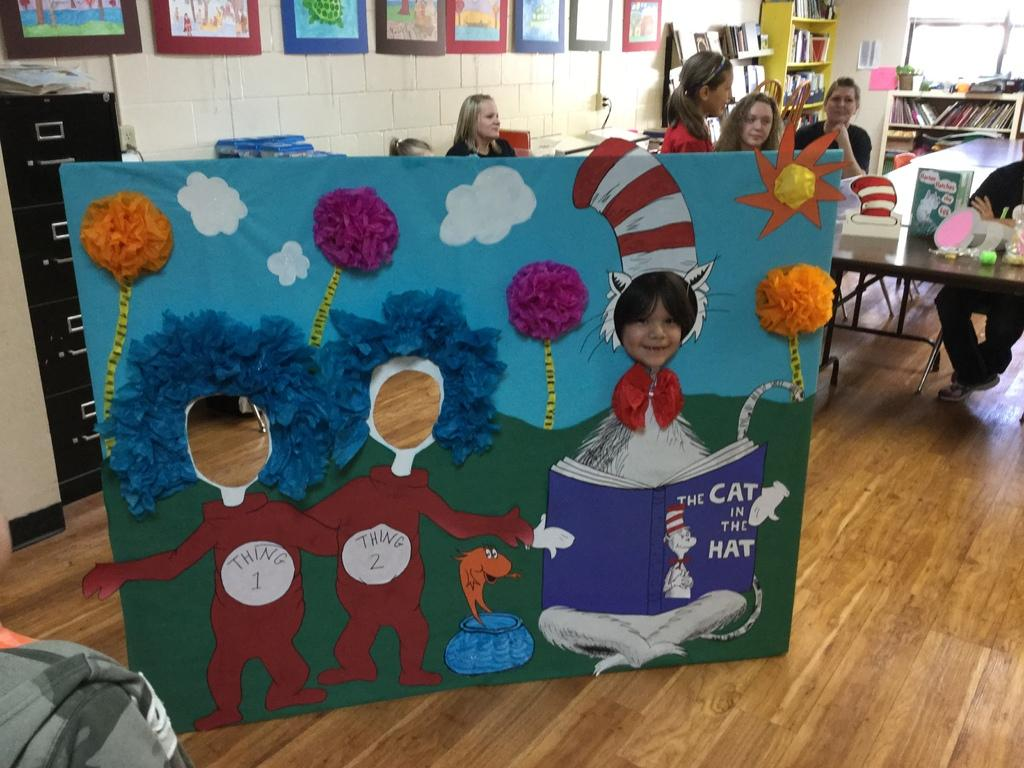Provide a one-sentence caption for the provided image. A Cat in the Hat display in a kindergarten classroom where a child is stick his head in the Cat in the hat's face slot. 